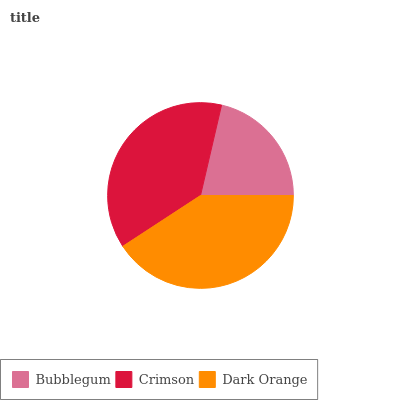Is Bubblegum the minimum?
Answer yes or no. Yes. Is Dark Orange the maximum?
Answer yes or no. Yes. Is Crimson the minimum?
Answer yes or no. No. Is Crimson the maximum?
Answer yes or no. No. Is Crimson greater than Bubblegum?
Answer yes or no. Yes. Is Bubblegum less than Crimson?
Answer yes or no. Yes. Is Bubblegum greater than Crimson?
Answer yes or no. No. Is Crimson less than Bubblegum?
Answer yes or no. No. Is Crimson the high median?
Answer yes or no. Yes. Is Crimson the low median?
Answer yes or no. Yes. Is Dark Orange the high median?
Answer yes or no. No. Is Dark Orange the low median?
Answer yes or no. No. 